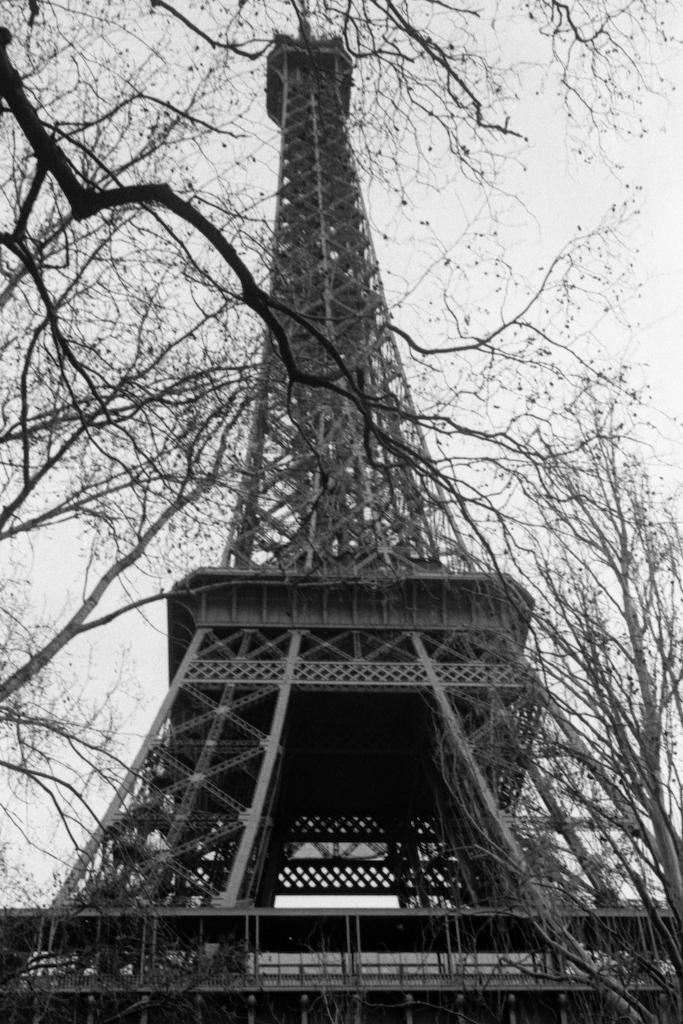What is the main structure in the image? There is a tower in the image. What type of natural elements can be seen in the image? Tree branches are visible in the image. What part of the natural environment is visible in the image? The sky is visible in the image. What scent can be detected from the image? There is no information about a scent in the image, as it only contains visual elements. 